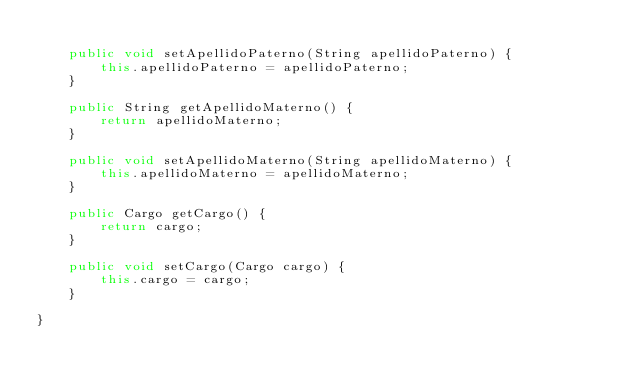Convert code to text. <code><loc_0><loc_0><loc_500><loc_500><_Java_>
    public void setApellidoPaterno(String apellidoPaterno) {
        this.apellidoPaterno = apellidoPaterno;
    }

    public String getApellidoMaterno() {
        return apellidoMaterno;
    }

    public void setApellidoMaterno(String apellidoMaterno) {
        this.apellidoMaterno = apellidoMaterno;
    }

    public Cargo getCargo() {
        return cargo;
    }

    public void setCargo(Cargo cargo) {
        this.cargo = cargo;
    }

}
</code> 